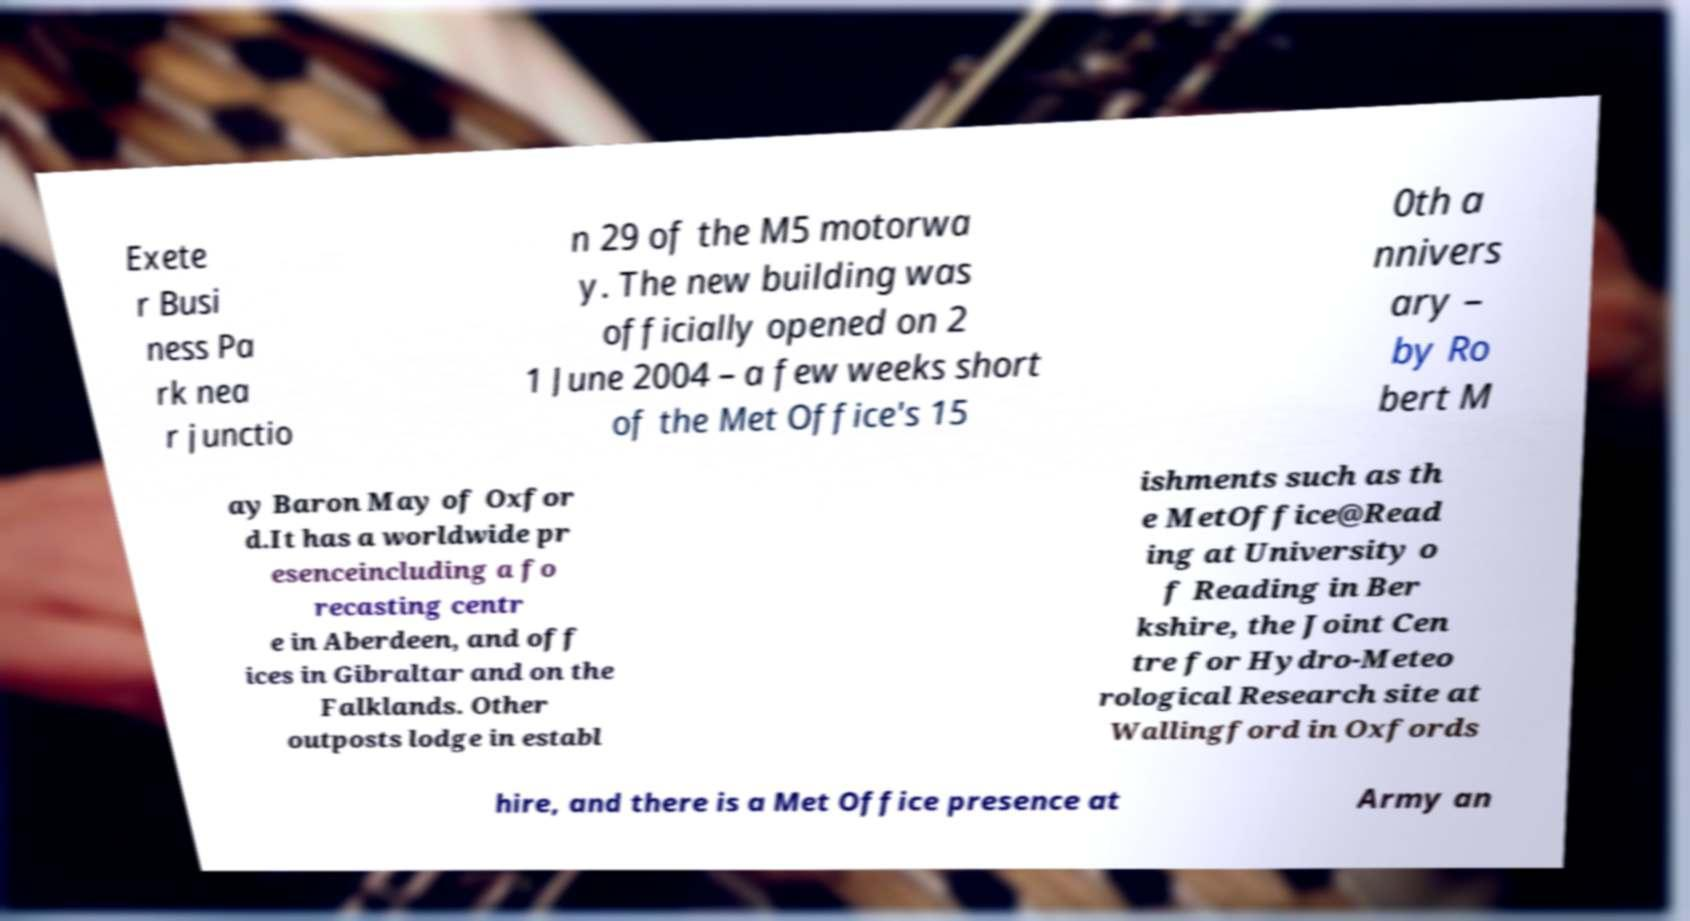Could you assist in decoding the text presented in this image and type it out clearly? Exete r Busi ness Pa rk nea r junctio n 29 of the M5 motorwa y. The new building was officially opened on 2 1 June 2004 – a few weeks short of the Met Office's 15 0th a nnivers ary – by Ro bert M ay Baron May of Oxfor d.It has a worldwide pr esenceincluding a fo recasting centr e in Aberdeen, and off ices in Gibraltar and on the Falklands. Other outposts lodge in establ ishments such as th e MetOffice@Read ing at University o f Reading in Ber kshire, the Joint Cen tre for Hydro-Meteo rological Research site at Wallingford in Oxfords hire, and there is a Met Office presence at Army an 